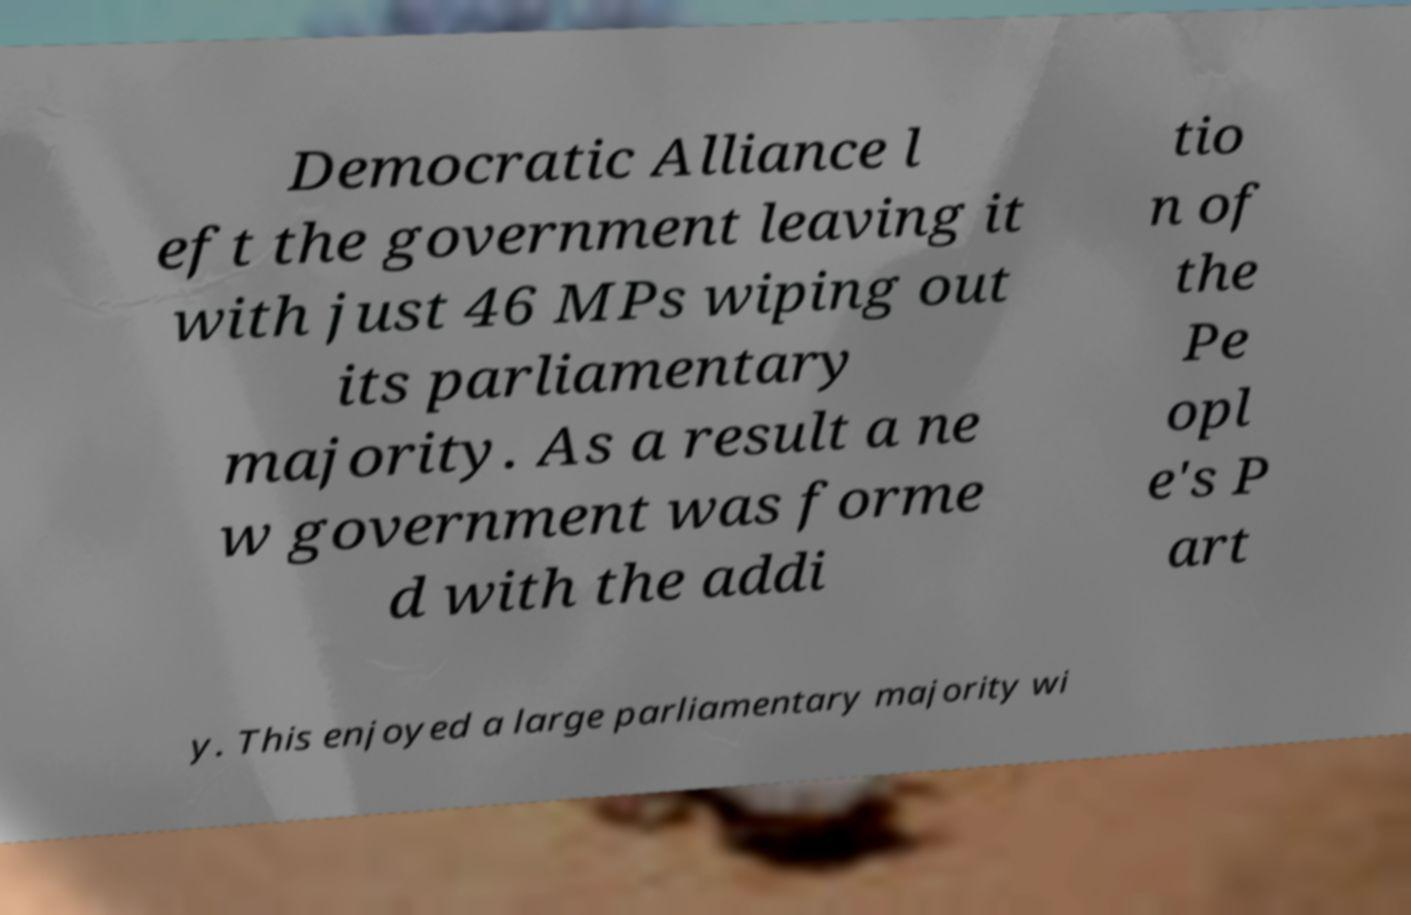Can you read and provide the text displayed in the image?This photo seems to have some interesting text. Can you extract and type it out for me? Democratic Alliance l eft the government leaving it with just 46 MPs wiping out its parliamentary majority. As a result a ne w government was forme d with the addi tio n of the Pe opl e's P art y. This enjoyed a large parliamentary majority wi 